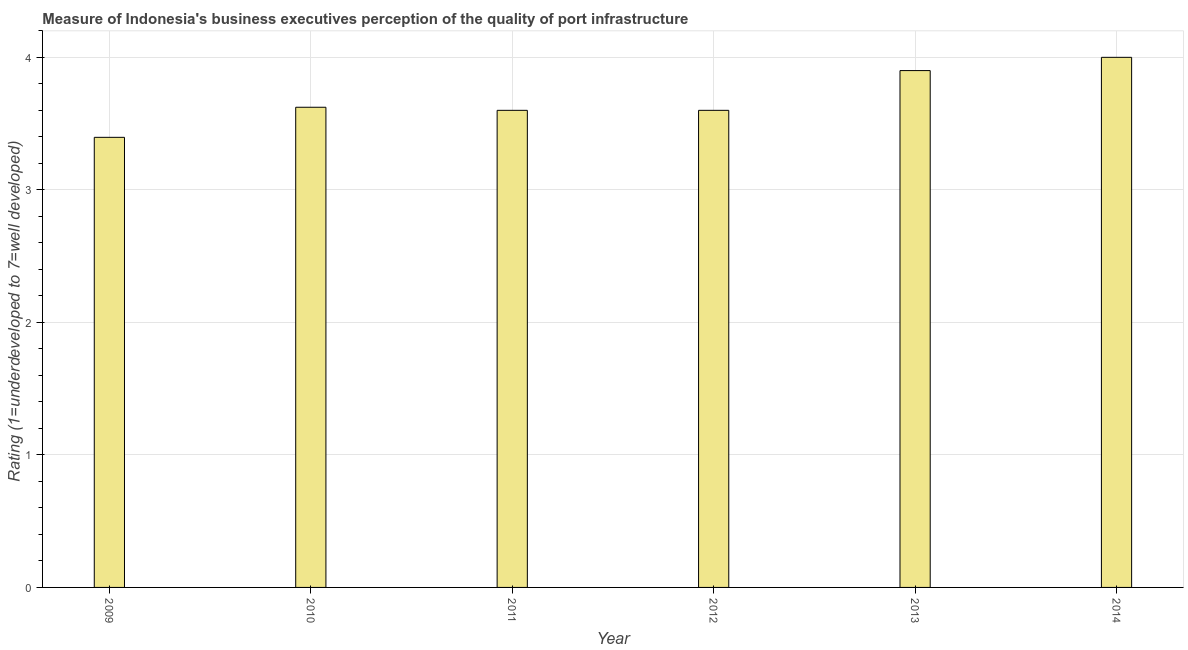Does the graph contain any zero values?
Your answer should be compact. No. Does the graph contain grids?
Your answer should be compact. Yes. What is the title of the graph?
Provide a succinct answer. Measure of Indonesia's business executives perception of the quality of port infrastructure. What is the label or title of the X-axis?
Your answer should be very brief. Year. What is the label or title of the Y-axis?
Offer a very short reply. Rating (1=underdeveloped to 7=well developed) . Across all years, what is the minimum rating measuring quality of port infrastructure?
Give a very brief answer. 3.4. In which year was the rating measuring quality of port infrastructure maximum?
Give a very brief answer. 2014. What is the sum of the rating measuring quality of port infrastructure?
Your answer should be very brief. 22.12. What is the difference between the rating measuring quality of port infrastructure in 2010 and 2012?
Ensure brevity in your answer.  0.02. What is the average rating measuring quality of port infrastructure per year?
Offer a very short reply. 3.69. What is the median rating measuring quality of port infrastructure?
Keep it short and to the point. 3.61. In how many years, is the rating measuring quality of port infrastructure greater than 2.2 ?
Your answer should be very brief. 6. Is the rating measuring quality of port infrastructure in 2012 less than that in 2014?
Keep it short and to the point. Yes. Is the difference between the rating measuring quality of port infrastructure in 2011 and 2012 greater than the difference between any two years?
Keep it short and to the point. No. How many bars are there?
Your answer should be very brief. 6. How many years are there in the graph?
Provide a short and direct response. 6. Are the values on the major ticks of Y-axis written in scientific E-notation?
Give a very brief answer. No. What is the Rating (1=underdeveloped to 7=well developed)  of 2009?
Your answer should be compact. 3.4. What is the Rating (1=underdeveloped to 7=well developed)  in 2010?
Make the answer very short. 3.62. What is the Rating (1=underdeveloped to 7=well developed)  of 2012?
Your response must be concise. 3.6. What is the Rating (1=underdeveloped to 7=well developed)  of 2013?
Provide a short and direct response. 3.9. What is the difference between the Rating (1=underdeveloped to 7=well developed)  in 2009 and 2010?
Keep it short and to the point. -0.23. What is the difference between the Rating (1=underdeveloped to 7=well developed)  in 2009 and 2011?
Give a very brief answer. -0.2. What is the difference between the Rating (1=underdeveloped to 7=well developed)  in 2009 and 2012?
Your response must be concise. -0.2. What is the difference between the Rating (1=underdeveloped to 7=well developed)  in 2009 and 2013?
Give a very brief answer. -0.5. What is the difference between the Rating (1=underdeveloped to 7=well developed)  in 2009 and 2014?
Ensure brevity in your answer.  -0.6. What is the difference between the Rating (1=underdeveloped to 7=well developed)  in 2010 and 2011?
Your answer should be compact. 0.02. What is the difference between the Rating (1=underdeveloped to 7=well developed)  in 2010 and 2012?
Provide a short and direct response. 0.02. What is the difference between the Rating (1=underdeveloped to 7=well developed)  in 2010 and 2013?
Ensure brevity in your answer.  -0.28. What is the difference between the Rating (1=underdeveloped to 7=well developed)  in 2010 and 2014?
Make the answer very short. -0.38. What is the difference between the Rating (1=underdeveloped to 7=well developed)  in 2011 and 2012?
Your answer should be compact. 0. What is the difference between the Rating (1=underdeveloped to 7=well developed)  in 2012 and 2013?
Ensure brevity in your answer.  -0.3. What is the difference between the Rating (1=underdeveloped to 7=well developed)  in 2013 and 2014?
Keep it short and to the point. -0.1. What is the ratio of the Rating (1=underdeveloped to 7=well developed)  in 2009 to that in 2010?
Ensure brevity in your answer.  0.94. What is the ratio of the Rating (1=underdeveloped to 7=well developed)  in 2009 to that in 2011?
Give a very brief answer. 0.94. What is the ratio of the Rating (1=underdeveloped to 7=well developed)  in 2009 to that in 2012?
Your response must be concise. 0.94. What is the ratio of the Rating (1=underdeveloped to 7=well developed)  in 2009 to that in 2013?
Your answer should be very brief. 0.87. What is the ratio of the Rating (1=underdeveloped to 7=well developed)  in 2009 to that in 2014?
Make the answer very short. 0.85. What is the ratio of the Rating (1=underdeveloped to 7=well developed)  in 2010 to that in 2013?
Give a very brief answer. 0.93. What is the ratio of the Rating (1=underdeveloped to 7=well developed)  in 2010 to that in 2014?
Your response must be concise. 0.91. What is the ratio of the Rating (1=underdeveloped to 7=well developed)  in 2011 to that in 2013?
Your answer should be compact. 0.92. What is the ratio of the Rating (1=underdeveloped to 7=well developed)  in 2012 to that in 2013?
Provide a short and direct response. 0.92. 